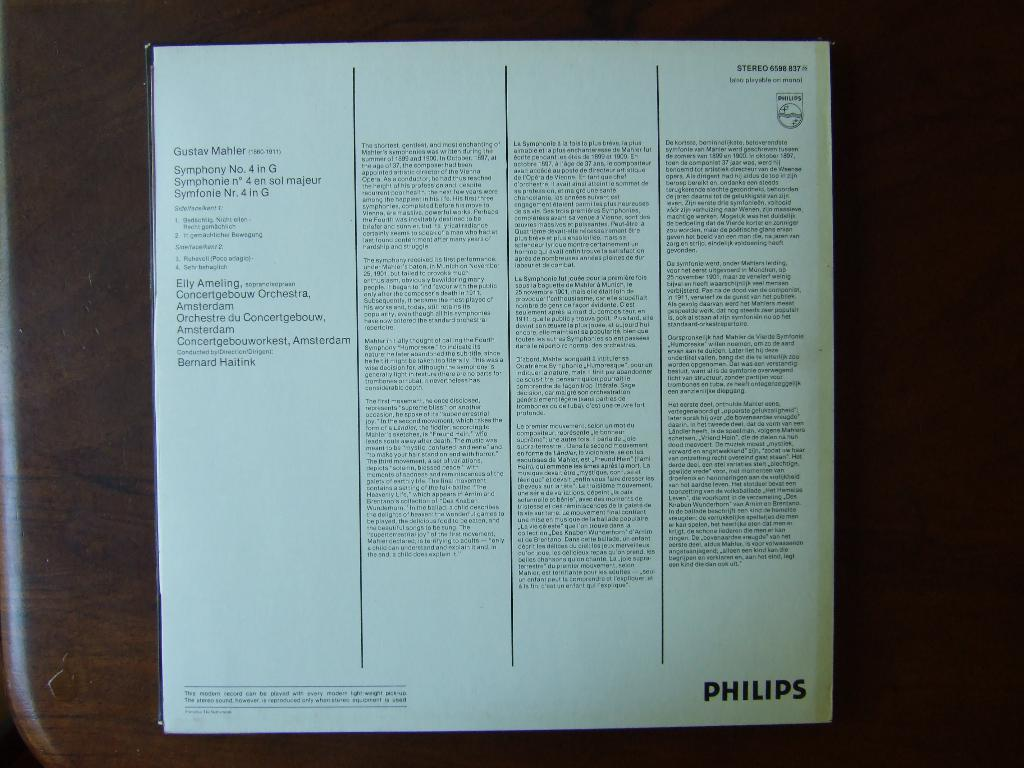<image>
Present a compact description of the photo's key features. a book with words on the back and 'philips' written on the bottom right of it 